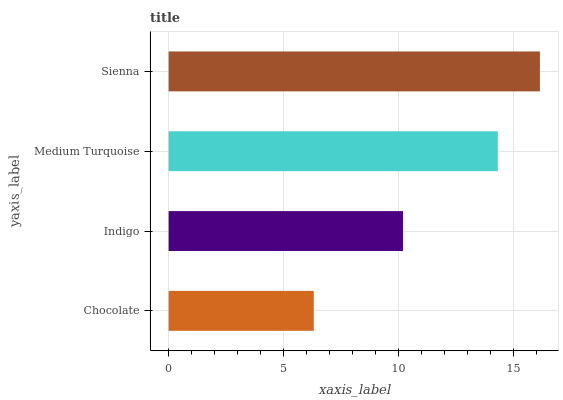Is Chocolate the minimum?
Answer yes or no. Yes. Is Sienna the maximum?
Answer yes or no. Yes. Is Indigo the minimum?
Answer yes or no. No. Is Indigo the maximum?
Answer yes or no. No. Is Indigo greater than Chocolate?
Answer yes or no. Yes. Is Chocolate less than Indigo?
Answer yes or no. Yes. Is Chocolate greater than Indigo?
Answer yes or no. No. Is Indigo less than Chocolate?
Answer yes or no. No. Is Medium Turquoise the high median?
Answer yes or no. Yes. Is Indigo the low median?
Answer yes or no. Yes. Is Sienna the high median?
Answer yes or no. No. Is Sienna the low median?
Answer yes or no. No. 